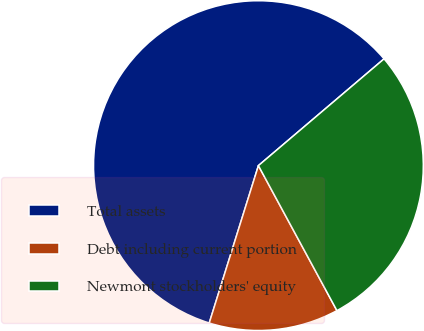<chart> <loc_0><loc_0><loc_500><loc_500><pie_chart><fcel>Total assets<fcel>Debt including current portion<fcel>Newmont stockholders' equity<nl><fcel>58.97%<fcel>12.72%<fcel>28.31%<nl></chart> 